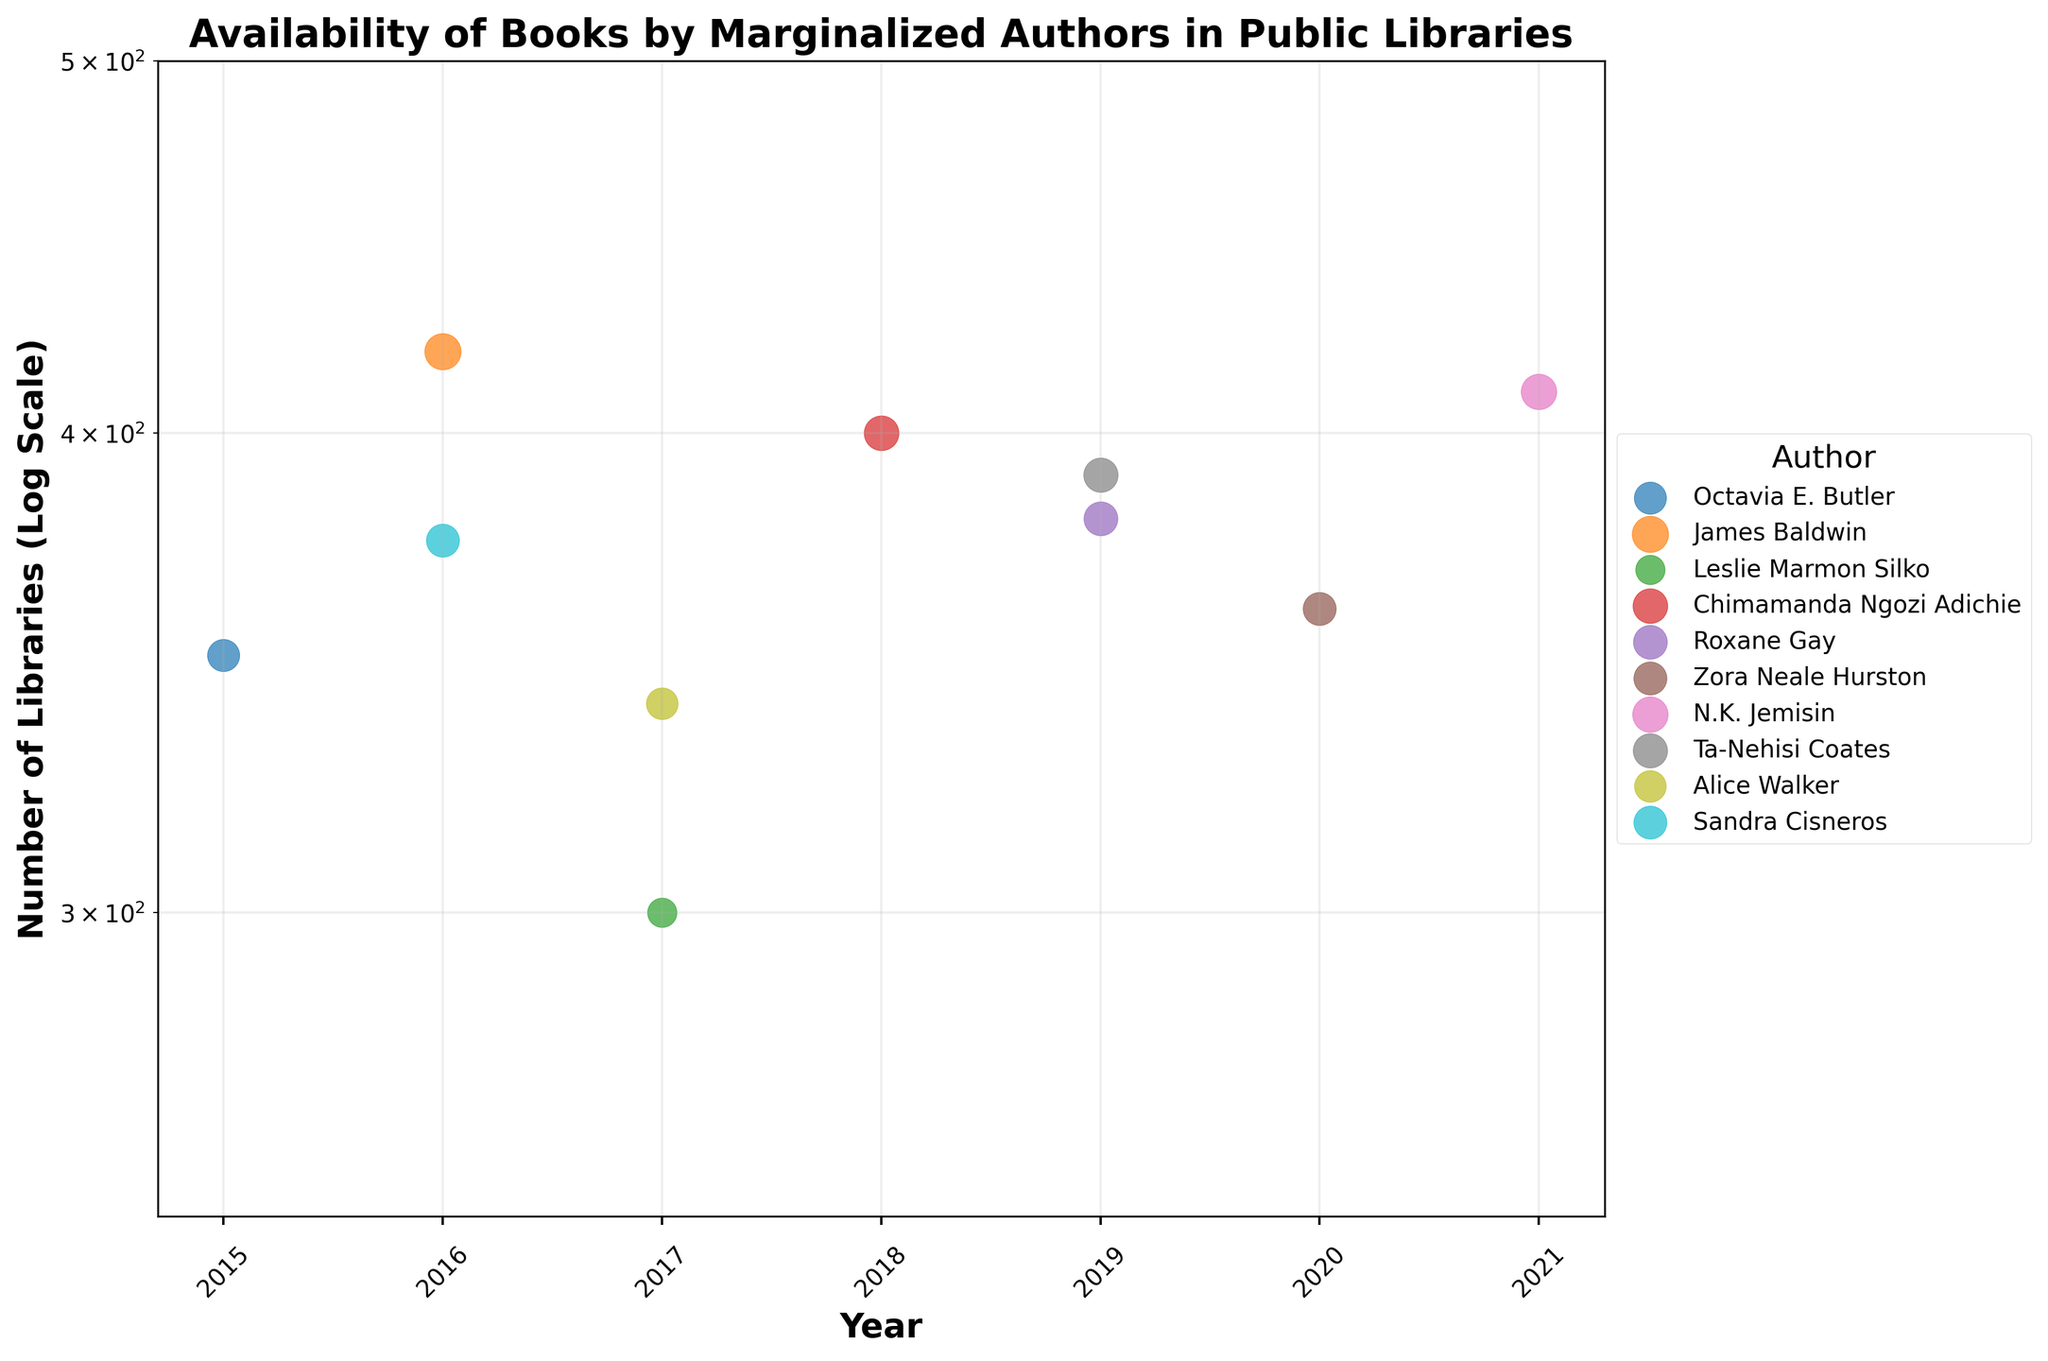What is the title of the plot? The title is at the top of the plot and labeled "Availability of Books by Marginalized Authors in Public Libraries".
Answer: Availability of Books by Marginalized Authors in Public Libraries Which author has the highest number of libraries listed for their books in 2021? N.K. Jemisin is labeled in the figure and has a data point in 2021, which is the highest on the y-axis for that year.
Answer: N.K. Jemisin How many authors have more than 375 libraries listed for any year? By examining each author's data points on the y-axis, we see James Baldwin, Chimamanda Ngozi Adichie, N.K. Jemisin, and Ta-Nehisi Coates represented by data points above 375.
Answer: 4 What is the largest size of a data point (bubble) in the plot? The size of the bubbles represents the number of available copies, so by comparing all the data points, James Baldwin's bubble appears largest, corresponding to the 2300 copies in 2016.
Answer: 2300 In which year are the fewest libraries carrying books by these authors? From the x-axis, surveying the vertical position of all data points in each year, 2017 has the fewest libraries, evidenced by the lower positions of data points for Leslie Marmon Silko and Alice Walker.
Answer: 2017 What is the range of libraries (from minimum to maximum) carrying books by Octavia E. Butler? Octavia E. Butler has data points at approximately 350 libraries in 2015; thus, the range is from 350 to 350.
Answer: 350 to 350 Compare the number of libraries for Roxane Gay and Ta-Nehisi Coates in 2019. Which author was more available? The y-axis positions for 2019 indicate 380 libraries for Roxane Gay and 390 libraries for Ta-Nehisi Coates; Coates has the higher value.
Answer: Ta-Nehisi Coates Between 2016 and 2020, which year shows the greatest variance in the number of libraries carrying books by the authors represented? By visually assessing the spread (vertical range) of data points for 2016-2020 on the y-axis, 2016 shows the greatest variance from roughly 350 to over 400 libraries.
Answer: 2016 What is the relationship between the number of libraries and the number of available copies for Leslie Marmon Silko in 2017? The data point for Leslie Marmon Silko in 2017 is around 300 libraries with a bubble size correlating to 1500 copies.
Answer: 300 libraries, 1500 copies Are more authors represented in 2016 or 2019 according to the plot? Counting the data points for each year along the x-axis, 2016 has three authors (James Baldwin, Sandra Cisneros, Octavia E. Butler) and 2019 also has three authors (Roxane Gay, Ta-Nehisi Coates, Chimamanda Ngozi Adichie), making the number equal.
Answer: Equal 